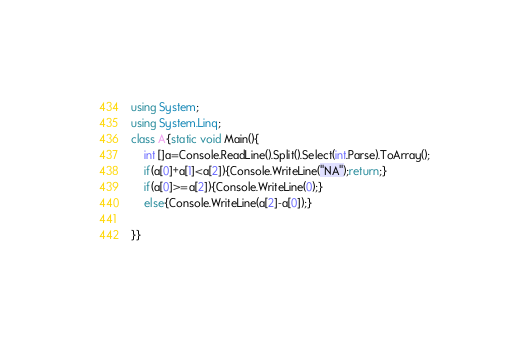Convert code to text. <code><loc_0><loc_0><loc_500><loc_500><_C#_>using System;
using System.Linq;
class A{static void Main(){
    int []a=Console.ReadLine().Split().Select(int.Parse).ToArray();
    if(a[0]+a[1]<a[2]){Console.WriteLine("NA");return;}
    if(a[0]>=a[2]){Console.WriteLine(0);}
    else{Console.WriteLine(a[2]-a[0]);}
    
}}</code> 